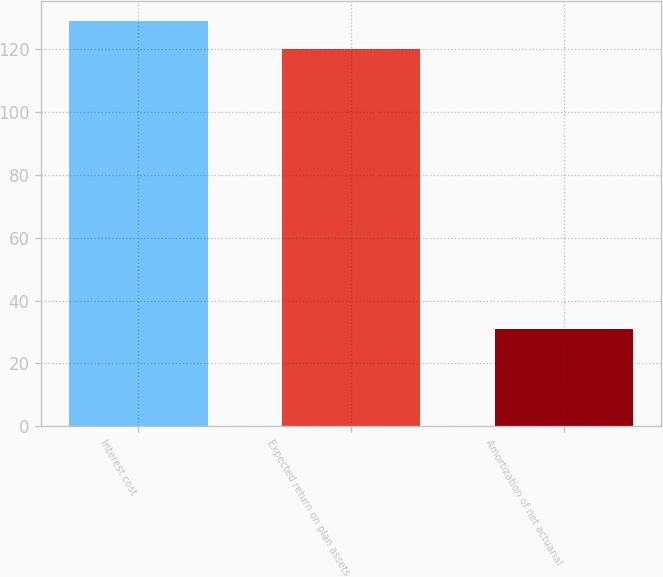Convert chart to OTSL. <chart><loc_0><loc_0><loc_500><loc_500><bar_chart><fcel>Interest cost<fcel>Expected return on plan assets<fcel>Amortization of net actuarial<nl><fcel>129.1<fcel>120<fcel>31<nl></chart> 